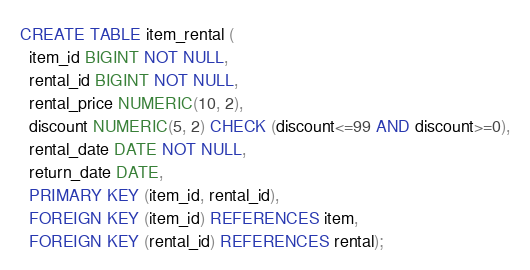<code> <loc_0><loc_0><loc_500><loc_500><_SQL_>CREATE TABLE item_rental (
  item_id BIGINT NOT NULL,
  rental_id BIGINT NOT NULL,
  rental_price NUMERIC(10, 2),
  discount NUMERIC(5, 2) CHECK (discount<=99 AND discount>=0),
  rental_date DATE NOT NULL,
  return_date DATE,
  PRIMARY KEY (item_id, rental_id),
  FOREIGN KEY (item_id) REFERENCES item,
  FOREIGN KEY (rental_id) REFERENCES rental);
</code> 